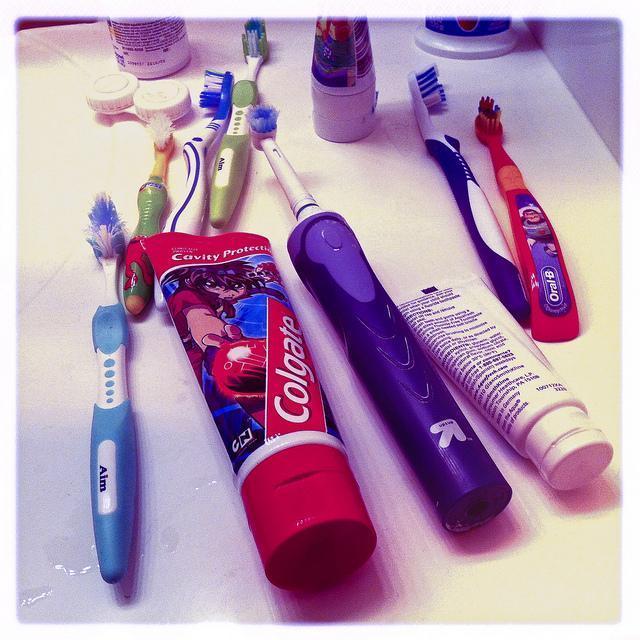How many toothbrushes are in this picture?
Give a very brief answer. 7. How many kids are using this toothpaste?
Give a very brief answer. 2. How many toothbrushes are there?
Give a very brief answer. 7. 